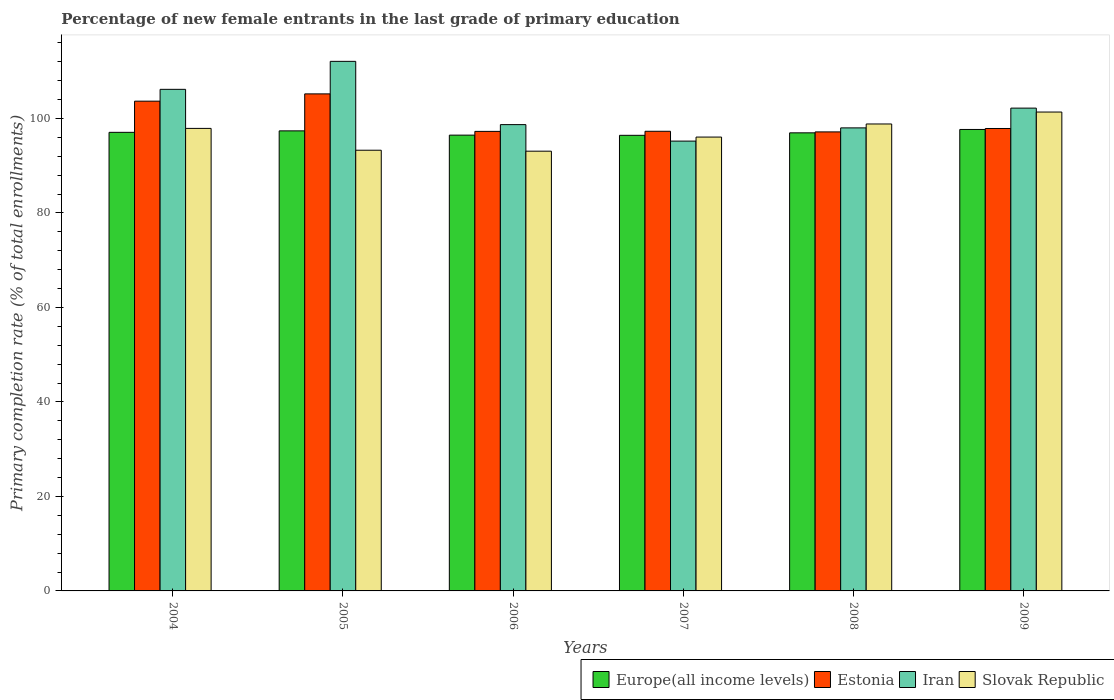Are the number of bars per tick equal to the number of legend labels?
Ensure brevity in your answer.  Yes. How many bars are there on the 6th tick from the left?
Provide a short and direct response. 4. How many bars are there on the 5th tick from the right?
Provide a succinct answer. 4. In how many cases, is the number of bars for a given year not equal to the number of legend labels?
Your answer should be very brief. 0. What is the percentage of new female entrants in Estonia in 2009?
Provide a succinct answer. 97.87. Across all years, what is the maximum percentage of new female entrants in Iran?
Give a very brief answer. 112.09. Across all years, what is the minimum percentage of new female entrants in Slovak Republic?
Your answer should be compact. 93.07. In which year was the percentage of new female entrants in Iran minimum?
Keep it short and to the point. 2007. What is the total percentage of new female entrants in Estonia in the graph?
Offer a terse response. 598.44. What is the difference between the percentage of new female entrants in Iran in 2005 and that in 2007?
Give a very brief answer. 16.88. What is the difference between the percentage of new female entrants in Iran in 2008 and the percentage of new female entrants in Europe(all income levels) in 2009?
Make the answer very short. 0.33. What is the average percentage of new female entrants in Slovak Republic per year?
Provide a short and direct response. 96.75. In the year 2005, what is the difference between the percentage of new female entrants in Estonia and percentage of new female entrants in Europe(all income levels)?
Offer a terse response. 7.83. In how many years, is the percentage of new female entrants in Estonia greater than 76 %?
Make the answer very short. 6. What is the ratio of the percentage of new female entrants in Slovak Republic in 2006 to that in 2009?
Offer a very short reply. 0.92. Is the difference between the percentage of new female entrants in Estonia in 2004 and 2007 greater than the difference between the percentage of new female entrants in Europe(all income levels) in 2004 and 2007?
Keep it short and to the point. Yes. What is the difference between the highest and the second highest percentage of new female entrants in Iran?
Your answer should be very brief. 5.92. What is the difference between the highest and the lowest percentage of new female entrants in Estonia?
Offer a terse response. 8.05. In how many years, is the percentage of new female entrants in Estonia greater than the average percentage of new female entrants in Estonia taken over all years?
Offer a terse response. 2. Is the sum of the percentage of new female entrants in Slovak Republic in 2006 and 2008 greater than the maximum percentage of new female entrants in Estonia across all years?
Provide a succinct answer. Yes. Is it the case that in every year, the sum of the percentage of new female entrants in Estonia and percentage of new female entrants in Europe(all income levels) is greater than the sum of percentage of new female entrants in Iran and percentage of new female entrants in Slovak Republic?
Make the answer very short. Yes. What does the 3rd bar from the left in 2009 represents?
Offer a very short reply. Iran. What does the 1st bar from the right in 2009 represents?
Give a very brief answer. Slovak Republic. Are all the bars in the graph horizontal?
Your response must be concise. No. What is the difference between two consecutive major ticks on the Y-axis?
Keep it short and to the point. 20. Does the graph contain any zero values?
Offer a very short reply. No. Does the graph contain grids?
Ensure brevity in your answer.  No. Where does the legend appear in the graph?
Your answer should be compact. Bottom right. What is the title of the graph?
Keep it short and to the point. Percentage of new female entrants in the last grade of primary education. What is the label or title of the Y-axis?
Provide a short and direct response. Primary completion rate (% of total enrollments). What is the Primary completion rate (% of total enrollments) of Europe(all income levels) in 2004?
Your answer should be very brief. 97.06. What is the Primary completion rate (% of total enrollments) of Estonia in 2004?
Your answer should be very brief. 103.66. What is the Primary completion rate (% of total enrollments) of Iran in 2004?
Keep it short and to the point. 106.16. What is the Primary completion rate (% of total enrollments) in Slovak Republic in 2004?
Offer a very short reply. 97.89. What is the Primary completion rate (% of total enrollments) in Europe(all income levels) in 2005?
Your answer should be compact. 97.37. What is the Primary completion rate (% of total enrollments) in Estonia in 2005?
Make the answer very short. 105.2. What is the Primary completion rate (% of total enrollments) of Iran in 2005?
Give a very brief answer. 112.09. What is the Primary completion rate (% of total enrollments) of Slovak Republic in 2005?
Offer a terse response. 93.27. What is the Primary completion rate (% of total enrollments) of Europe(all income levels) in 2006?
Your answer should be very brief. 96.47. What is the Primary completion rate (% of total enrollments) in Estonia in 2006?
Ensure brevity in your answer.  97.26. What is the Primary completion rate (% of total enrollments) in Iran in 2006?
Offer a very short reply. 98.69. What is the Primary completion rate (% of total enrollments) of Slovak Republic in 2006?
Your answer should be compact. 93.07. What is the Primary completion rate (% of total enrollments) in Europe(all income levels) in 2007?
Offer a very short reply. 96.43. What is the Primary completion rate (% of total enrollments) in Estonia in 2007?
Offer a very short reply. 97.29. What is the Primary completion rate (% of total enrollments) in Iran in 2007?
Offer a very short reply. 95.21. What is the Primary completion rate (% of total enrollments) in Slovak Republic in 2007?
Your answer should be compact. 96.06. What is the Primary completion rate (% of total enrollments) in Europe(all income levels) in 2008?
Give a very brief answer. 96.96. What is the Primary completion rate (% of total enrollments) of Estonia in 2008?
Ensure brevity in your answer.  97.15. What is the Primary completion rate (% of total enrollments) in Iran in 2008?
Keep it short and to the point. 98. What is the Primary completion rate (% of total enrollments) of Slovak Republic in 2008?
Your answer should be very brief. 98.83. What is the Primary completion rate (% of total enrollments) of Europe(all income levels) in 2009?
Provide a succinct answer. 97.67. What is the Primary completion rate (% of total enrollments) in Estonia in 2009?
Provide a short and direct response. 97.87. What is the Primary completion rate (% of total enrollments) of Iran in 2009?
Your answer should be compact. 102.19. What is the Primary completion rate (% of total enrollments) in Slovak Republic in 2009?
Ensure brevity in your answer.  101.36. Across all years, what is the maximum Primary completion rate (% of total enrollments) in Europe(all income levels)?
Offer a very short reply. 97.67. Across all years, what is the maximum Primary completion rate (% of total enrollments) of Estonia?
Offer a very short reply. 105.2. Across all years, what is the maximum Primary completion rate (% of total enrollments) of Iran?
Keep it short and to the point. 112.09. Across all years, what is the maximum Primary completion rate (% of total enrollments) of Slovak Republic?
Provide a succinct answer. 101.36. Across all years, what is the minimum Primary completion rate (% of total enrollments) in Europe(all income levels)?
Your answer should be compact. 96.43. Across all years, what is the minimum Primary completion rate (% of total enrollments) in Estonia?
Offer a terse response. 97.15. Across all years, what is the minimum Primary completion rate (% of total enrollments) of Iran?
Provide a succinct answer. 95.21. Across all years, what is the minimum Primary completion rate (% of total enrollments) in Slovak Republic?
Your response must be concise. 93.07. What is the total Primary completion rate (% of total enrollments) in Europe(all income levels) in the graph?
Give a very brief answer. 581.96. What is the total Primary completion rate (% of total enrollments) of Estonia in the graph?
Provide a short and direct response. 598.44. What is the total Primary completion rate (% of total enrollments) in Iran in the graph?
Your answer should be very brief. 612.34. What is the total Primary completion rate (% of total enrollments) in Slovak Republic in the graph?
Give a very brief answer. 580.49. What is the difference between the Primary completion rate (% of total enrollments) of Europe(all income levels) in 2004 and that in 2005?
Provide a short and direct response. -0.31. What is the difference between the Primary completion rate (% of total enrollments) in Estonia in 2004 and that in 2005?
Your answer should be very brief. -1.54. What is the difference between the Primary completion rate (% of total enrollments) in Iran in 2004 and that in 2005?
Offer a very short reply. -5.92. What is the difference between the Primary completion rate (% of total enrollments) of Slovak Republic in 2004 and that in 2005?
Make the answer very short. 4.62. What is the difference between the Primary completion rate (% of total enrollments) of Europe(all income levels) in 2004 and that in 2006?
Give a very brief answer. 0.59. What is the difference between the Primary completion rate (% of total enrollments) in Estonia in 2004 and that in 2006?
Keep it short and to the point. 6.4. What is the difference between the Primary completion rate (% of total enrollments) in Iran in 2004 and that in 2006?
Provide a succinct answer. 7.47. What is the difference between the Primary completion rate (% of total enrollments) in Slovak Republic in 2004 and that in 2006?
Provide a short and direct response. 4.82. What is the difference between the Primary completion rate (% of total enrollments) of Europe(all income levels) in 2004 and that in 2007?
Ensure brevity in your answer.  0.63. What is the difference between the Primary completion rate (% of total enrollments) in Estonia in 2004 and that in 2007?
Provide a short and direct response. 6.37. What is the difference between the Primary completion rate (% of total enrollments) of Iran in 2004 and that in 2007?
Ensure brevity in your answer.  10.96. What is the difference between the Primary completion rate (% of total enrollments) in Slovak Republic in 2004 and that in 2007?
Your answer should be very brief. 1.84. What is the difference between the Primary completion rate (% of total enrollments) of Europe(all income levels) in 2004 and that in 2008?
Keep it short and to the point. 0.11. What is the difference between the Primary completion rate (% of total enrollments) of Estonia in 2004 and that in 2008?
Your answer should be very brief. 6.51. What is the difference between the Primary completion rate (% of total enrollments) of Iran in 2004 and that in 2008?
Your response must be concise. 8.16. What is the difference between the Primary completion rate (% of total enrollments) in Slovak Republic in 2004 and that in 2008?
Keep it short and to the point. -0.94. What is the difference between the Primary completion rate (% of total enrollments) of Europe(all income levels) in 2004 and that in 2009?
Offer a terse response. -0.61. What is the difference between the Primary completion rate (% of total enrollments) of Estonia in 2004 and that in 2009?
Offer a very short reply. 5.79. What is the difference between the Primary completion rate (% of total enrollments) of Iran in 2004 and that in 2009?
Your answer should be very brief. 3.98. What is the difference between the Primary completion rate (% of total enrollments) in Slovak Republic in 2004 and that in 2009?
Offer a very short reply. -3.46. What is the difference between the Primary completion rate (% of total enrollments) in Europe(all income levels) in 2005 and that in 2006?
Provide a succinct answer. 0.9. What is the difference between the Primary completion rate (% of total enrollments) in Estonia in 2005 and that in 2006?
Ensure brevity in your answer.  7.94. What is the difference between the Primary completion rate (% of total enrollments) of Iran in 2005 and that in 2006?
Make the answer very short. 13.39. What is the difference between the Primary completion rate (% of total enrollments) of Slovak Republic in 2005 and that in 2006?
Keep it short and to the point. 0.2. What is the difference between the Primary completion rate (% of total enrollments) in Europe(all income levels) in 2005 and that in 2007?
Make the answer very short. 0.94. What is the difference between the Primary completion rate (% of total enrollments) of Estonia in 2005 and that in 2007?
Offer a very short reply. 7.91. What is the difference between the Primary completion rate (% of total enrollments) of Iran in 2005 and that in 2007?
Keep it short and to the point. 16.88. What is the difference between the Primary completion rate (% of total enrollments) of Slovak Republic in 2005 and that in 2007?
Your answer should be compact. -2.78. What is the difference between the Primary completion rate (% of total enrollments) of Europe(all income levels) in 2005 and that in 2008?
Ensure brevity in your answer.  0.42. What is the difference between the Primary completion rate (% of total enrollments) in Estonia in 2005 and that in 2008?
Your answer should be compact. 8.05. What is the difference between the Primary completion rate (% of total enrollments) in Iran in 2005 and that in 2008?
Your response must be concise. 14.08. What is the difference between the Primary completion rate (% of total enrollments) of Slovak Republic in 2005 and that in 2008?
Your answer should be very brief. -5.55. What is the difference between the Primary completion rate (% of total enrollments) in Europe(all income levels) in 2005 and that in 2009?
Provide a succinct answer. -0.3. What is the difference between the Primary completion rate (% of total enrollments) of Estonia in 2005 and that in 2009?
Your answer should be compact. 7.33. What is the difference between the Primary completion rate (% of total enrollments) in Iran in 2005 and that in 2009?
Keep it short and to the point. 9.9. What is the difference between the Primary completion rate (% of total enrollments) of Slovak Republic in 2005 and that in 2009?
Your response must be concise. -8.08. What is the difference between the Primary completion rate (% of total enrollments) of Europe(all income levels) in 2006 and that in 2007?
Make the answer very short. 0.04. What is the difference between the Primary completion rate (% of total enrollments) of Estonia in 2006 and that in 2007?
Your answer should be compact. -0.02. What is the difference between the Primary completion rate (% of total enrollments) in Iran in 2006 and that in 2007?
Offer a very short reply. 3.49. What is the difference between the Primary completion rate (% of total enrollments) of Slovak Republic in 2006 and that in 2007?
Keep it short and to the point. -2.99. What is the difference between the Primary completion rate (% of total enrollments) in Europe(all income levels) in 2006 and that in 2008?
Make the answer very short. -0.49. What is the difference between the Primary completion rate (% of total enrollments) of Estonia in 2006 and that in 2008?
Make the answer very short. 0.11. What is the difference between the Primary completion rate (% of total enrollments) of Iran in 2006 and that in 2008?
Provide a short and direct response. 0.69. What is the difference between the Primary completion rate (% of total enrollments) in Slovak Republic in 2006 and that in 2008?
Give a very brief answer. -5.76. What is the difference between the Primary completion rate (% of total enrollments) of Europe(all income levels) in 2006 and that in 2009?
Your answer should be compact. -1.2. What is the difference between the Primary completion rate (% of total enrollments) in Estonia in 2006 and that in 2009?
Your response must be concise. -0.61. What is the difference between the Primary completion rate (% of total enrollments) in Iran in 2006 and that in 2009?
Your response must be concise. -3.49. What is the difference between the Primary completion rate (% of total enrollments) of Slovak Republic in 2006 and that in 2009?
Your response must be concise. -8.29. What is the difference between the Primary completion rate (% of total enrollments) in Europe(all income levels) in 2007 and that in 2008?
Your answer should be very brief. -0.53. What is the difference between the Primary completion rate (% of total enrollments) in Estonia in 2007 and that in 2008?
Your answer should be very brief. 0.13. What is the difference between the Primary completion rate (% of total enrollments) of Iran in 2007 and that in 2008?
Offer a very short reply. -2.8. What is the difference between the Primary completion rate (% of total enrollments) in Slovak Republic in 2007 and that in 2008?
Your response must be concise. -2.77. What is the difference between the Primary completion rate (% of total enrollments) of Europe(all income levels) in 2007 and that in 2009?
Offer a very short reply. -1.24. What is the difference between the Primary completion rate (% of total enrollments) of Estonia in 2007 and that in 2009?
Offer a very short reply. -0.59. What is the difference between the Primary completion rate (% of total enrollments) in Iran in 2007 and that in 2009?
Provide a short and direct response. -6.98. What is the difference between the Primary completion rate (% of total enrollments) of Slovak Republic in 2007 and that in 2009?
Your answer should be compact. -5.3. What is the difference between the Primary completion rate (% of total enrollments) of Europe(all income levels) in 2008 and that in 2009?
Keep it short and to the point. -0.72. What is the difference between the Primary completion rate (% of total enrollments) of Estonia in 2008 and that in 2009?
Your answer should be compact. -0.72. What is the difference between the Primary completion rate (% of total enrollments) of Iran in 2008 and that in 2009?
Provide a succinct answer. -4.18. What is the difference between the Primary completion rate (% of total enrollments) of Slovak Republic in 2008 and that in 2009?
Your answer should be very brief. -2.53. What is the difference between the Primary completion rate (% of total enrollments) in Europe(all income levels) in 2004 and the Primary completion rate (% of total enrollments) in Estonia in 2005?
Your answer should be compact. -8.14. What is the difference between the Primary completion rate (% of total enrollments) of Europe(all income levels) in 2004 and the Primary completion rate (% of total enrollments) of Iran in 2005?
Keep it short and to the point. -15.02. What is the difference between the Primary completion rate (% of total enrollments) in Europe(all income levels) in 2004 and the Primary completion rate (% of total enrollments) in Slovak Republic in 2005?
Ensure brevity in your answer.  3.79. What is the difference between the Primary completion rate (% of total enrollments) in Estonia in 2004 and the Primary completion rate (% of total enrollments) in Iran in 2005?
Offer a very short reply. -8.43. What is the difference between the Primary completion rate (% of total enrollments) of Estonia in 2004 and the Primary completion rate (% of total enrollments) of Slovak Republic in 2005?
Your answer should be very brief. 10.38. What is the difference between the Primary completion rate (% of total enrollments) of Iran in 2004 and the Primary completion rate (% of total enrollments) of Slovak Republic in 2005?
Give a very brief answer. 12.89. What is the difference between the Primary completion rate (% of total enrollments) in Europe(all income levels) in 2004 and the Primary completion rate (% of total enrollments) in Estonia in 2006?
Provide a succinct answer. -0.2. What is the difference between the Primary completion rate (% of total enrollments) of Europe(all income levels) in 2004 and the Primary completion rate (% of total enrollments) of Iran in 2006?
Ensure brevity in your answer.  -1.63. What is the difference between the Primary completion rate (% of total enrollments) in Europe(all income levels) in 2004 and the Primary completion rate (% of total enrollments) in Slovak Republic in 2006?
Offer a very short reply. 3.99. What is the difference between the Primary completion rate (% of total enrollments) of Estonia in 2004 and the Primary completion rate (% of total enrollments) of Iran in 2006?
Provide a short and direct response. 4.96. What is the difference between the Primary completion rate (% of total enrollments) of Estonia in 2004 and the Primary completion rate (% of total enrollments) of Slovak Republic in 2006?
Offer a terse response. 10.59. What is the difference between the Primary completion rate (% of total enrollments) in Iran in 2004 and the Primary completion rate (% of total enrollments) in Slovak Republic in 2006?
Your response must be concise. 13.09. What is the difference between the Primary completion rate (% of total enrollments) in Europe(all income levels) in 2004 and the Primary completion rate (% of total enrollments) in Estonia in 2007?
Provide a short and direct response. -0.23. What is the difference between the Primary completion rate (% of total enrollments) in Europe(all income levels) in 2004 and the Primary completion rate (% of total enrollments) in Iran in 2007?
Provide a succinct answer. 1.86. What is the difference between the Primary completion rate (% of total enrollments) of Europe(all income levels) in 2004 and the Primary completion rate (% of total enrollments) of Slovak Republic in 2007?
Keep it short and to the point. 1. What is the difference between the Primary completion rate (% of total enrollments) of Estonia in 2004 and the Primary completion rate (% of total enrollments) of Iran in 2007?
Give a very brief answer. 8.45. What is the difference between the Primary completion rate (% of total enrollments) of Estonia in 2004 and the Primary completion rate (% of total enrollments) of Slovak Republic in 2007?
Provide a short and direct response. 7.6. What is the difference between the Primary completion rate (% of total enrollments) of Iran in 2004 and the Primary completion rate (% of total enrollments) of Slovak Republic in 2007?
Offer a very short reply. 10.1. What is the difference between the Primary completion rate (% of total enrollments) in Europe(all income levels) in 2004 and the Primary completion rate (% of total enrollments) in Estonia in 2008?
Give a very brief answer. -0.09. What is the difference between the Primary completion rate (% of total enrollments) of Europe(all income levels) in 2004 and the Primary completion rate (% of total enrollments) of Iran in 2008?
Provide a succinct answer. -0.94. What is the difference between the Primary completion rate (% of total enrollments) of Europe(all income levels) in 2004 and the Primary completion rate (% of total enrollments) of Slovak Republic in 2008?
Give a very brief answer. -1.77. What is the difference between the Primary completion rate (% of total enrollments) of Estonia in 2004 and the Primary completion rate (% of total enrollments) of Iran in 2008?
Provide a short and direct response. 5.65. What is the difference between the Primary completion rate (% of total enrollments) of Estonia in 2004 and the Primary completion rate (% of total enrollments) of Slovak Republic in 2008?
Your answer should be very brief. 4.83. What is the difference between the Primary completion rate (% of total enrollments) of Iran in 2004 and the Primary completion rate (% of total enrollments) of Slovak Republic in 2008?
Your answer should be compact. 7.33. What is the difference between the Primary completion rate (% of total enrollments) of Europe(all income levels) in 2004 and the Primary completion rate (% of total enrollments) of Estonia in 2009?
Offer a terse response. -0.81. What is the difference between the Primary completion rate (% of total enrollments) in Europe(all income levels) in 2004 and the Primary completion rate (% of total enrollments) in Iran in 2009?
Your response must be concise. -5.13. What is the difference between the Primary completion rate (% of total enrollments) in Europe(all income levels) in 2004 and the Primary completion rate (% of total enrollments) in Slovak Republic in 2009?
Provide a short and direct response. -4.3. What is the difference between the Primary completion rate (% of total enrollments) in Estonia in 2004 and the Primary completion rate (% of total enrollments) in Iran in 2009?
Offer a very short reply. 1.47. What is the difference between the Primary completion rate (% of total enrollments) of Estonia in 2004 and the Primary completion rate (% of total enrollments) of Slovak Republic in 2009?
Provide a succinct answer. 2.3. What is the difference between the Primary completion rate (% of total enrollments) in Iran in 2004 and the Primary completion rate (% of total enrollments) in Slovak Republic in 2009?
Your response must be concise. 4.8. What is the difference between the Primary completion rate (% of total enrollments) in Europe(all income levels) in 2005 and the Primary completion rate (% of total enrollments) in Estonia in 2006?
Offer a terse response. 0.11. What is the difference between the Primary completion rate (% of total enrollments) of Europe(all income levels) in 2005 and the Primary completion rate (% of total enrollments) of Iran in 2006?
Ensure brevity in your answer.  -1.32. What is the difference between the Primary completion rate (% of total enrollments) in Europe(all income levels) in 2005 and the Primary completion rate (% of total enrollments) in Slovak Republic in 2006?
Your answer should be compact. 4.3. What is the difference between the Primary completion rate (% of total enrollments) in Estonia in 2005 and the Primary completion rate (% of total enrollments) in Iran in 2006?
Make the answer very short. 6.51. What is the difference between the Primary completion rate (% of total enrollments) of Estonia in 2005 and the Primary completion rate (% of total enrollments) of Slovak Republic in 2006?
Your response must be concise. 12.13. What is the difference between the Primary completion rate (% of total enrollments) in Iran in 2005 and the Primary completion rate (% of total enrollments) in Slovak Republic in 2006?
Make the answer very short. 19.01. What is the difference between the Primary completion rate (% of total enrollments) of Europe(all income levels) in 2005 and the Primary completion rate (% of total enrollments) of Estonia in 2007?
Your answer should be very brief. 0.09. What is the difference between the Primary completion rate (% of total enrollments) in Europe(all income levels) in 2005 and the Primary completion rate (% of total enrollments) in Iran in 2007?
Provide a short and direct response. 2.17. What is the difference between the Primary completion rate (% of total enrollments) of Europe(all income levels) in 2005 and the Primary completion rate (% of total enrollments) of Slovak Republic in 2007?
Your response must be concise. 1.31. What is the difference between the Primary completion rate (% of total enrollments) of Estonia in 2005 and the Primary completion rate (% of total enrollments) of Iran in 2007?
Give a very brief answer. 10. What is the difference between the Primary completion rate (% of total enrollments) of Estonia in 2005 and the Primary completion rate (% of total enrollments) of Slovak Republic in 2007?
Make the answer very short. 9.14. What is the difference between the Primary completion rate (% of total enrollments) in Iran in 2005 and the Primary completion rate (% of total enrollments) in Slovak Republic in 2007?
Provide a short and direct response. 16.03. What is the difference between the Primary completion rate (% of total enrollments) of Europe(all income levels) in 2005 and the Primary completion rate (% of total enrollments) of Estonia in 2008?
Give a very brief answer. 0.22. What is the difference between the Primary completion rate (% of total enrollments) of Europe(all income levels) in 2005 and the Primary completion rate (% of total enrollments) of Iran in 2008?
Your answer should be very brief. -0.63. What is the difference between the Primary completion rate (% of total enrollments) in Europe(all income levels) in 2005 and the Primary completion rate (% of total enrollments) in Slovak Republic in 2008?
Offer a terse response. -1.46. What is the difference between the Primary completion rate (% of total enrollments) in Estonia in 2005 and the Primary completion rate (% of total enrollments) in Iran in 2008?
Your answer should be very brief. 7.2. What is the difference between the Primary completion rate (% of total enrollments) of Estonia in 2005 and the Primary completion rate (% of total enrollments) of Slovak Republic in 2008?
Give a very brief answer. 6.37. What is the difference between the Primary completion rate (% of total enrollments) in Iran in 2005 and the Primary completion rate (% of total enrollments) in Slovak Republic in 2008?
Keep it short and to the point. 13.26. What is the difference between the Primary completion rate (% of total enrollments) in Europe(all income levels) in 2005 and the Primary completion rate (% of total enrollments) in Estonia in 2009?
Offer a terse response. -0.5. What is the difference between the Primary completion rate (% of total enrollments) in Europe(all income levels) in 2005 and the Primary completion rate (% of total enrollments) in Iran in 2009?
Keep it short and to the point. -4.81. What is the difference between the Primary completion rate (% of total enrollments) of Europe(all income levels) in 2005 and the Primary completion rate (% of total enrollments) of Slovak Republic in 2009?
Ensure brevity in your answer.  -3.98. What is the difference between the Primary completion rate (% of total enrollments) in Estonia in 2005 and the Primary completion rate (% of total enrollments) in Iran in 2009?
Keep it short and to the point. 3.01. What is the difference between the Primary completion rate (% of total enrollments) in Estonia in 2005 and the Primary completion rate (% of total enrollments) in Slovak Republic in 2009?
Ensure brevity in your answer.  3.84. What is the difference between the Primary completion rate (% of total enrollments) in Iran in 2005 and the Primary completion rate (% of total enrollments) in Slovak Republic in 2009?
Your response must be concise. 10.73. What is the difference between the Primary completion rate (% of total enrollments) of Europe(all income levels) in 2006 and the Primary completion rate (% of total enrollments) of Estonia in 2007?
Provide a short and direct response. -0.82. What is the difference between the Primary completion rate (% of total enrollments) in Europe(all income levels) in 2006 and the Primary completion rate (% of total enrollments) in Iran in 2007?
Your response must be concise. 1.26. What is the difference between the Primary completion rate (% of total enrollments) in Europe(all income levels) in 2006 and the Primary completion rate (% of total enrollments) in Slovak Republic in 2007?
Your answer should be compact. 0.41. What is the difference between the Primary completion rate (% of total enrollments) of Estonia in 2006 and the Primary completion rate (% of total enrollments) of Iran in 2007?
Offer a terse response. 2.06. What is the difference between the Primary completion rate (% of total enrollments) of Estonia in 2006 and the Primary completion rate (% of total enrollments) of Slovak Republic in 2007?
Your response must be concise. 1.2. What is the difference between the Primary completion rate (% of total enrollments) of Iran in 2006 and the Primary completion rate (% of total enrollments) of Slovak Republic in 2007?
Offer a terse response. 2.63. What is the difference between the Primary completion rate (% of total enrollments) in Europe(all income levels) in 2006 and the Primary completion rate (% of total enrollments) in Estonia in 2008?
Your answer should be very brief. -0.68. What is the difference between the Primary completion rate (% of total enrollments) of Europe(all income levels) in 2006 and the Primary completion rate (% of total enrollments) of Iran in 2008?
Your response must be concise. -1.53. What is the difference between the Primary completion rate (% of total enrollments) of Europe(all income levels) in 2006 and the Primary completion rate (% of total enrollments) of Slovak Republic in 2008?
Make the answer very short. -2.36. What is the difference between the Primary completion rate (% of total enrollments) in Estonia in 2006 and the Primary completion rate (% of total enrollments) in Iran in 2008?
Keep it short and to the point. -0.74. What is the difference between the Primary completion rate (% of total enrollments) in Estonia in 2006 and the Primary completion rate (% of total enrollments) in Slovak Republic in 2008?
Give a very brief answer. -1.57. What is the difference between the Primary completion rate (% of total enrollments) of Iran in 2006 and the Primary completion rate (% of total enrollments) of Slovak Republic in 2008?
Your response must be concise. -0.14. What is the difference between the Primary completion rate (% of total enrollments) of Europe(all income levels) in 2006 and the Primary completion rate (% of total enrollments) of Estonia in 2009?
Give a very brief answer. -1.4. What is the difference between the Primary completion rate (% of total enrollments) in Europe(all income levels) in 2006 and the Primary completion rate (% of total enrollments) in Iran in 2009?
Offer a very short reply. -5.72. What is the difference between the Primary completion rate (% of total enrollments) in Europe(all income levels) in 2006 and the Primary completion rate (% of total enrollments) in Slovak Republic in 2009?
Your answer should be compact. -4.89. What is the difference between the Primary completion rate (% of total enrollments) in Estonia in 2006 and the Primary completion rate (% of total enrollments) in Iran in 2009?
Offer a terse response. -4.92. What is the difference between the Primary completion rate (% of total enrollments) in Estonia in 2006 and the Primary completion rate (% of total enrollments) in Slovak Republic in 2009?
Give a very brief answer. -4.09. What is the difference between the Primary completion rate (% of total enrollments) in Iran in 2006 and the Primary completion rate (% of total enrollments) in Slovak Republic in 2009?
Your answer should be compact. -2.66. What is the difference between the Primary completion rate (% of total enrollments) in Europe(all income levels) in 2007 and the Primary completion rate (% of total enrollments) in Estonia in 2008?
Provide a succinct answer. -0.72. What is the difference between the Primary completion rate (% of total enrollments) of Europe(all income levels) in 2007 and the Primary completion rate (% of total enrollments) of Iran in 2008?
Your answer should be compact. -1.58. What is the difference between the Primary completion rate (% of total enrollments) of Europe(all income levels) in 2007 and the Primary completion rate (% of total enrollments) of Slovak Republic in 2008?
Ensure brevity in your answer.  -2.4. What is the difference between the Primary completion rate (% of total enrollments) in Estonia in 2007 and the Primary completion rate (% of total enrollments) in Iran in 2008?
Offer a very short reply. -0.72. What is the difference between the Primary completion rate (% of total enrollments) in Estonia in 2007 and the Primary completion rate (% of total enrollments) in Slovak Republic in 2008?
Provide a succinct answer. -1.54. What is the difference between the Primary completion rate (% of total enrollments) in Iran in 2007 and the Primary completion rate (% of total enrollments) in Slovak Republic in 2008?
Make the answer very short. -3.62. What is the difference between the Primary completion rate (% of total enrollments) in Europe(all income levels) in 2007 and the Primary completion rate (% of total enrollments) in Estonia in 2009?
Make the answer very short. -1.44. What is the difference between the Primary completion rate (% of total enrollments) of Europe(all income levels) in 2007 and the Primary completion rate (% of total enrollments) of Iran in 2009?
Offer a terse response. -5.76. What is the difference between the Primary completion rate (% of total enrollments) of Europe(all income levels) in 2007 and the Primary completion rate (% of total enrollments) of Slovak Republic in 2009?
Your answer should be compact. -4.93. What is the difference between the Primary completion rate (% of total enrollments) in Estonia in 2007 and the Primary completion rate (% of total enrollments) in Iran in 2009?
Your answer should be very brief. -4.9. What is the difference between the Primary completion rate (% of total enrollments) of Estonia in 2007 and the Primary completion rate (% of total enrollments) of Slovak Republic in 2009?
Offer a very short reply. -4.07. What is the difference between the Primary completion rate (% of total enrollments) in Iran in 2007 and the Primary completion rate (% of total enrollments) in Slovak Republic in 2009?
Your answer should be compact. -6.15. What is the difference between the Primary completion rate (% of total enrollments) in Europe(all income levels) in 2008 and the Primary completion rate (% of total enrollments) in Estonia in 2009?
Make the answer very short. -0.92. What is the difference between the Primary completion rate (% of total enrollments) of Europe(all income levels) in 2008 and the Primary completion rate (% of total enrollments) of Iran in 2009?
Your answer should be compact. -5.23. What is the difference between the Primary completion rate (% of total enrollments) of Europe(all income levels) in 2008 and the Primary completion rate (% of total enrollments) of Slovak Republic in 2009?
Your answer should be compact. -4.4. What is the difference between the Primary completion rate (% of total enrollments) of Estonia in 2008 and the Primary completion rate (% of total enrollments) of Iran in 2009?
Offer a terse response. -5.03. What is the difference between the Primary completion rate (% of total enrollments) in Estonia in 2008 and the Primary completion rate (% of total enrollments) in Slovak Republic in 2009?
Keep it short and to the point. -4.2. What is the difference between the Primary completion rate (% of total enrollments) in Iran in 2008 and the Primary completion rate (% of total enrollments) in Slovak Republic in 2009?
Your answer should be compact. -3.35. What is the average Primary completion rate (% of total enrollments) in Europe(all income levels) per year?
Make the answer very short. 96.99. What is the average Primary completion rate (% of total enrollments) of Estonia per year?
Your answer should be compact. 99.74. What is the average Primary completion rate (% of total enrollments) of Iran per year?
Your answer should be compact. 102.06. What is the average Primary completion rate (% of total enrollments) in Slovak Republic per year?
Ensure brevity in your answer.  96.75. In the year 2004, what is the difference between the Primary completion rate (% of total enrollments) in Europe(all income levels) and Primary completion rate (% of total enrollments) in Estonia?
Ensure brevity in your answer.  -6.6. In the year 2004, what is the difference between the Primary completion rate (% of total enrollments) in Europe(all income levels) and Primary completion rate (% of total enrollments) in Iran?
Keep it short and to the point. -9.1. In the year 2004, what is the difference between the Primary completion rate (% of total enrollments) in Europe(all income levels) and Primary completion rate (% of total enrollments) in Slovak Republic?
Provide a short and direct response. -0.83. In the year 2004, what is the difference between the Primary completion rate (% of total enrollments) in Estonia and Primary completion rate (% of total enrollments) in Iran?
Give a very brief answer. -2.5. In the year 2004, what is the difference between the Primary completion rate (% of total enrollments) in Estonia and Primary completion rate (% of total enrollments) in Slovak Republic?
Ensure brevity in your answer.  5.76. In the year 2004, what is the difference between the Primary completion rate (% of total enrollments) of Iran and Primary completion rate (% of total enrollments) of Slovak Republic?
Your answer should be compact. 8.27. In the year 2005, what is the difference between the Primary completion rate (% of total enrollments) in Europe(all income levels) and Primary completion rate (% of total enrollments) in Estonia?
Your response must be concise. -7.83. In the year 2005, what is the difference between the Primary completion rate (% of total enrollments) in Europe(all income levels) and Primary completion rate (% of total enrollments) in Iran?
Make the answer very short. -14.71. In the year 2005, what is the difference between the Primary completion rate (% of total enrollments) in Europe(all income levels) and Primary completion rate (% of total enrollments) in Slovak Republic?
Make the answer very short. 4.1. In the year 2005, what is the difference between the Primary completion rate (% of total enrollments) in Estonia and Primary completion rate (% of total enrollments) in Iran?
Make the answer very short. -6.88. In the year 2005, what is the difference between the Primary completion rate (% of total enrollments) in Estonia and Primary completion rate (% of total enrollments) in Slovak Republic?
Your answer should be compact. 11.93. In the year 2005, what is the difference between the Primary completion rate (% of total enrollments) in Iran and Primary completion rate (% of total enrollments) in Slovak Republic?
Offer a very short reply. 18.81. In the year 2006, what is the difference between the Primary completion rate (% of total enrollments) of Europe(all income levels) and Primary completion rate (% of total enrollments) of Estonia?
Provide a succinct answer. -0.79. In the year 2006, what is the difference between the Primary completion rate (% of total enrollments) in Europe(all income levels) and Primary completion rate (% of total enrollments) in Iran?
Your answer should be very brief. -2.22. In the year 2006, what is the difference between the Primary completion rate (% of total enrollments) of Europe(all income levels) and Primary completion rate (% of total enrollments) of Slovak Republic?
Provide a succinct answer. 3.4. In the year 2006, what is the difference between the Primary completion rate (% of total enrollments) of Estonia and Primary completion rate (% of total enrollments) of Iran?
Provide a succinct answer. -1.43. In the year 2006, what is the difference between the Primary completion rate (% of total enrollments) in Estonia and Primary completion rate (% of total enrollments) in Slovak Republic?
Provide a short and direct response. 4.19. In the year 2006, what is the difference between the Primary completion rate (% of total enrollments) in Iran and Primary completion rate (% of total enrollments) in Slovak Republic?
Offer a very short reply. 5.62. In the year 2007, what is the difference between the Primary completion rate (% of total enrollments) in Europe(all income levels) and Primary completion rate (% of total enrollments) in Estonia?
Your response must be concise. -0.86. In the year 2007, what is the difference between the Primary completion rate (% of total enrollments) of Europe(all income levels) and Primary completion rate (% of total enrollments) of Iran?
Your response must be concise. 1.22. In the year 2007, what is the difference between the Primary completion rate (% of total enrollments) of Europe(all income levels) and Primary completion rate (% of total enrollments) of Slovak Republic?
Provide a succinct answer. 0.37. In the year 2007, what is the difference between the Primary completion rate (% of total enrollments) in Estonia and Primary completion rate (% of total enrollments) in Iran?
Provide a short and direct response. 2.08. In the year 2007, what is the difference between the Primary completion rate (% of total enrollments) of Estonia and Primary completion rate (% of total enrollments) of Slovak Republic?
Provide a short and direct response. 1.23. In the year 2007, what is the difference between the Primary completion rate (% of total enrollments) of Iran and Primary completion rate (% of total enrollments) of Slovak Republic?
Your response must be concise. -0.85. In the year 2008, what is the difference between the Primary completion rate (% of total enrollments) in Europe(all income levels) and Primary completion rate (% of total enrollments) in Estonia?
Offer a very short reply. -0.2. In the year 2008, what is the difference between the Primary completion rate (% of total enrollments) in Europe(all income levels) and Primary completion rate (% of total enrollments) in Iran?
Offer a very short reply. -1.05. In the year 2008, what is the difference between the Primary completion rate (% of total enrollments) in Europe(all income levels) and Primary completion rate (% of total enrollments) in Slovak Republic?
Your answer should be very brief. -1.87. In the year 2008, what is the difference between the Primary completion rate (% of total enrollments) of Estonia and Primary completion rate (% of total enrollments) of Iran?
Make the answer very short. -0.85. In the year 2008, what is the difference between the Primary completion rate (% of total enrollments) of Estonia and Primary completion rate (% of total enrollments) of Slovak Republic?
Offer a terse response. -1.68. In the year 2008, what is the difference between the Primary completion rate (% of total enrollments) in Iran and Primary completion rate (% of total enrollments) in Slovak Republic?
Offer a very short reply. -0.82. In the year 2009, what is the difference between the Primary completion rate (% of total enrollments) of Europe(all income levels) and Primary completion rate (% of total enrollments) of Estonia?
Provide a short and direct response. -0.2. In the year 2009, what is the difference between the Primary completion rate (% of total enrollments) of Europe(all income levels) and Primary completion rate (% of total enrollments) of Iran?
Your answer should be very brief. -4.52. In the year 2009, what is the difference between the Primary completion rate (% of total enrollments) of Europe(all income levels) and Primary completion rate (% of total enrollments) of Slovak Republic?
Provide a short and direct response. -3.69. In the year 2009, what is the difference between the Primary completion rate (% of total enrollments) of Estonia and Primary completion rate (% of total enrollments) of Iran?
Provide a succinct answer. -4.31. In the year 2009, what is the difference between the Primary completion rate (% of total enrollments) in Estonia and Primary completion rate (% of total enrollments) in Slovak Republic?
Offer a very short reply. -3.48. In the year 2009, what is the difference between the Primary completion rate (% of total enrollments) in Iran and Primary completion rate (% of total enrollments) in Slovak Republic?
Give a very brief answer. 0.83. What is the ratio of the Primary completion rate (% of total enrollments) in Estonia in 2004 to that in 2005?
Make the answer very short. 0.99. What is the ratio of the Primary completion rate (% of total enrollments) of Iran in 2004 to that in 2005?
Ensure brevity in your answer.  0.95. What is the ratio of the Primary completion rate (% of total enrollments) in Slovak Republic in 2004 to that in 2005?
Your response must be concise. 1.05. What is the ratio of the Primary completion rate (% of total enrollments) of Europe(all income levels) in 2004 to that in 2006?
Offer a terse response. 1.01. What is the ratio of the Primary completion rate (% of total enrollments) in Estonia in 2004 to that in 2006?
Ensure brevity in your answer.  1.07. What is the ratio of the Primary completion rate (% of total enrollments) in Iran in 2004 to that in 2006?
Your answer should be compact. 1.08. What is the ratio of the Primary completion rate (% of total enrollments) of Slovak Republic in 2004 to that in 2006?
Your answer should be very brief. 1.05. What is the ratio of the Primary completion rate (% of total enrollments) in Europe(all income levels) in 2004 to that in 2007?
Your response must be concise. 1.01. What is the ratio of the Primary completion rate (% of total enrollments) in Estonia in 2004 to that in 2007?
Your response must be concise. 1.07. What is the ratio of the Primary completion rate (% of total enrollments) of Iran in 2004 to that in 2007?
Provide a short and direct response. 1.12. What is the ratio of the Primary completion rate (% of total enrollments) of Slovak Republic in 2004 to that in 2007?
Ensure brevity in your answer.  1.02. What is the ratio of the Primary completion rate (% of total enrollments) of Europe(all income levels) in 2004 to that in 2008?
Your answer should be compact. 1. What is the ratio of the Primary completion rate (% of total enrollments) of Estonia in 2004 to that in 2008?
Ensure brevity in your answer.  1.07. What is the ratio of the Primary completion rate (% of total enrollments) in Iran in 2004 to that in 2008?
Your response must be concise. 1.08. What is the ratio of the Primary completion rate (% of total enrollments) of Europe(all income levels) in 2004 to that in 2009?
Provide a succinct answer. 0.99. What is the ratio of the Primary completion rate (% of total enrollments) of Estonia in 2004 to that in 2009?
Make the answer very short. 1.06. What is the ratio of the Primary completion rate (% of total enrollments) of Iran in 2004 to that in 2009?
Ensure brevity in your answer.  1.04. What is the ratio of the Primary completion rate (% of total enrollments) of Slovak Republic in 2004 to that in 2009?
Your answer should be very brief. 0.97. What is the ratio of the Primary completion rate (% of total enrollments) of Europe(all income levels) in 2005 to that in 2006?
Give a very brief answer. 1.01. What is the ratio of the Primary completion rate (% of total enrollments) in Estonia in 2005 to that in 2006?
Make the answer very short. 1.08. What is the ratio of the Primary completion rate (% of total enrollments) of Iran in 2005 to that in 2006?
Give a very brief answer. 1.14. What is the ratio of the Primary completion rate (% of total enrollments) of Europe(all income levels) in 2005 to that in 2007?
Offer a terse response. 1.01. What is the ratio of the Primary completion rate (% of total enrollments) of Estonia in 2005 to that in 2007?
Offer a very short reply. 1.08. What is the ratio of the Primary completion rate (% of total enrollments) in Iran in 2005 to that in 2007?
Ensure brevity in your answer.  1.18. What is the ratio of the Primary completion rate (% of total enrollments) of Slovak Republic in 2005 to that in 2007?
Keep it short and to the point. 0.97. What is the ratio of the Primary completion rate (% of total enrollments) of Europe(all income levels) in 2005 to that in 2008?
Your answer should be very brief. 1. What is the ratio of the Primary completion rate (% of total enrollments) in Estonia in 2005 to that in 2008?
Your response must be concise. 1.08. What is the ratio of the Primary completion rate (% of total enrollments) in Iran in 2005 to that in 2008?
Your answer should be compact. 1.14. What is the ratio of the Primary completion rate (% of total enrollments) of Slovak Republic in 2005 to that in 2008?
Your response must be concise. 0.94. What is the ratio of the Primary completion rate (% of total enrollments) of Europe(all income levels) in 2005 to that in 2009?
Provide a short and direct response. 1. What is the ratio of the Primary completion rate (% of total enrollments) of Estonia in 2005 to that in 2009?
Make the answer very short. 1.07. What is the ratio of the Primary completion rate (% of total enrollments) in Iran in 2005 to that in 2009?
Provide a succinct answer. 1.1. What is the ratio of the Primary completion rate (% of total enrollments) in Slovak Republic in 2005 to that in 2009?
Your answer should be compact. 0.92. What is the ratio of the Primary completion rate (% of total enrollments) in Estonia in 2006 to that in 2007?
Give a very brief answer. 1. What is the ratio of the Primary completion rate (% of total enrollments) in Iran in 2006 to that in 2007?
Keep it short and to the point. 1.04. What is the ratio of the Primary completion rate (% of total enrollments) in Slovak Republic in 2006 to that in 2007?
Keep it short and to the point. 0.97. What is the ratio of the Primary completion rate (% of total enrollments) in Estonia in 2006 to that in 2008?
Provide a succinct answer. 1. What is the ratio of the Primary completion rate (% of total enrollments) of Slovak Republic in 2006 to that in 2008?
Ensure brevity in your answer.  0.94. What is the ratio of the Primary completion rate (% of total enrollments) of Europe(all income levels) in 2006 to that in 2009?
Your answer should be compact. 0.99. What is the ratio of the Primary completion rate (% of total enrollments) of Iran in 2006 to that in 2009?
Offer a terse response. 0.97. What is the ratio of the Primary completion rate (% of total enrollments) in Slovak Republic in 2006 to that in 2009?
Ensure brevity in your answer.  0.92. What is the ratio of the Primary completion rate (% of total enrollments) of Iran in 2007 to that in 2008?
Offer a very short reply. 0.97. What is the ratio of the Primary completion rate (% of total enrollments) in Slovak Republic in 2007 to that in 2008?
Ensure brevity in your answer.  0.97. What is the ratio of the Primary completion rate (% of total enrollments) in Europe(all income levels) in 2007 to that in 2009?
Offer a very short reply. 0.99. What is the ratio of the Primary completion rate (% of total enrollments) of Estonia in 2007 to that in 2009?
Provide a succinct answer. 0.99. What is the ratio of the Primary completion rate (% of total enrollments) in Iran in 2007 to that in 2009?
Offer a terse response. 0.93. What is the ratio of the Primary completion rate (% of total enrollments) in Slovak Republic in 2007 to that in 2009?
Give a very brief answer. 0.95. What is the ratio of the Primary completion rate (% of total enrollments) in Europe(all income levels) in 2008 to that in 2009?
Your answer should be compact. 0.99. What is the ratio of the Primary completion rate (% of total enrollments) in Iran in 2008 to that in 2009?
Offer a very short reply. 0.96. What is the ratio of the Primary completion rate (% of total enrollments) of Slovak Republic in 2008 to that in 2009?
Make the answer very short. 0.98. What is the difference between the highest and the second highest Primary completion rate (% of total enrollments) in Europe(all income levels)?
Give a very brief answer. 0.3. What is the difference between the highest and the second highest Primary completion rate (% of total enrollments) in Estonia?
Your response must be concise. 1.54. What is the difference between the highest and the second highest Primary completion rate (% of total enrollments) in Iran?
Offer a very short reply. 5.92. What is the difference between the highest and the second highest Primary completion rate (% of total enrollments) of Slovak Republic?
Offer a terse response. 2.53. What is the difference between the highest and the lowest Primary completion rate (% of total enrollments) in Europe(all income levels)?
Offer a very short reply. 1.24. What is the difference between the highest and the lowest Primary completion rate (% of total enrollments) of Estonia?
Keep it short and to the point. 8.05. What is the difference between the highest and the lowest Primary completion rate (% of total enrollments) of Iran?
Your response must be concise. 16.88. What is the difference between the highest and the lowest Primary completion rate (% of total enrollments) in Slovak Republic?
Make the answer very short. 8.29. 